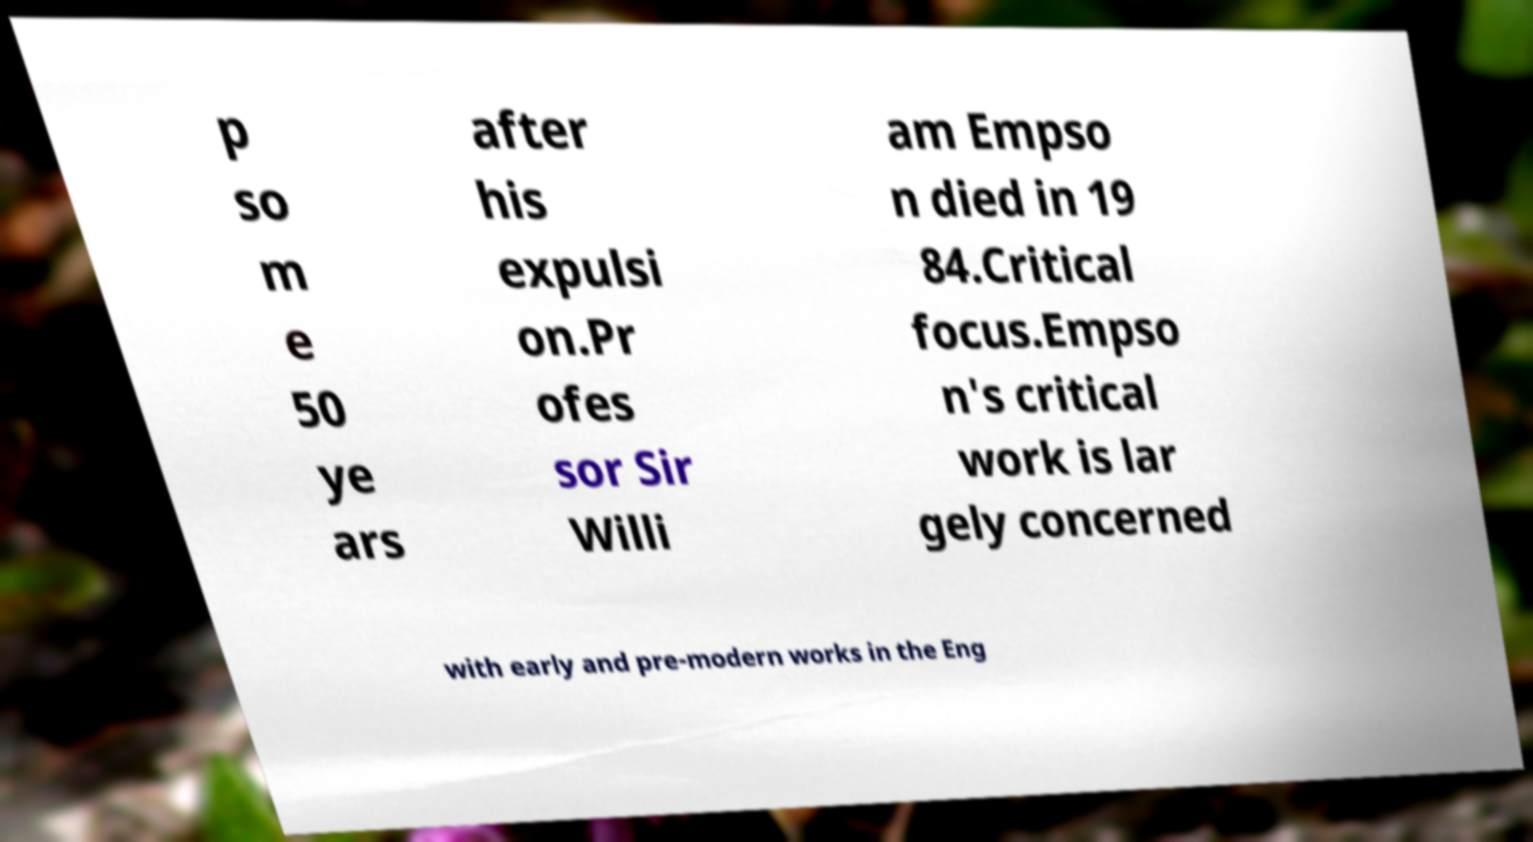Can you read and provide the text displayed in the image?This photo seems to have some interesting text. Can you extract and type it out for me? p so m e 50 ye ars after his expulsi on.Pr ofes sor Sir Willi am Empso n died in 19 84.Critical focus.Empso n's critical work is lar gely concerned with early and pre-modern works in the Eng 